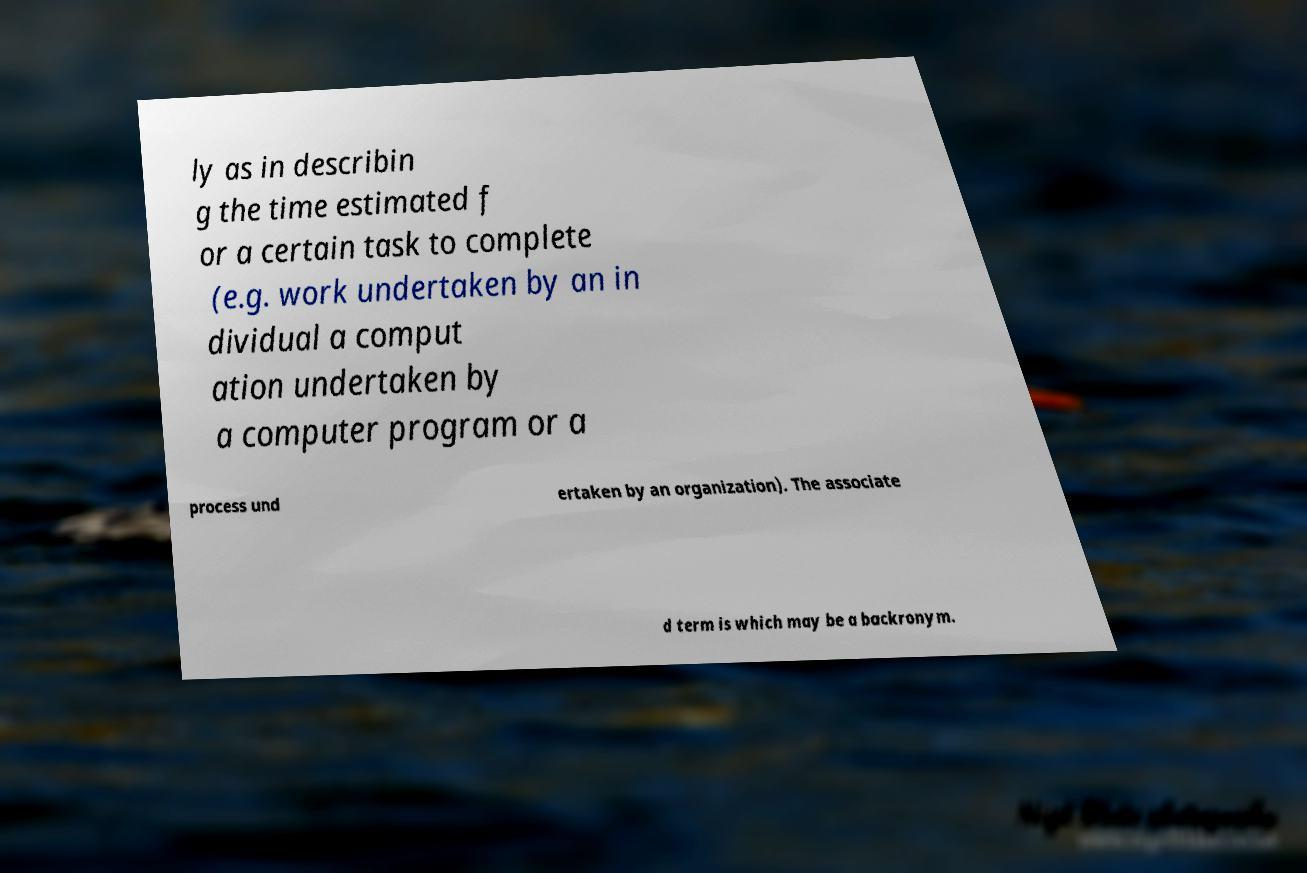Please read and relay the text visible in this image. What does it say? ly as in describin g the time estimated f or a certain task to complete (e.g. work undertaken by an in dividual a comput ation undertaken by a computer program or a process und ertaken by an organization). The associate d term is which may be a backronym. 